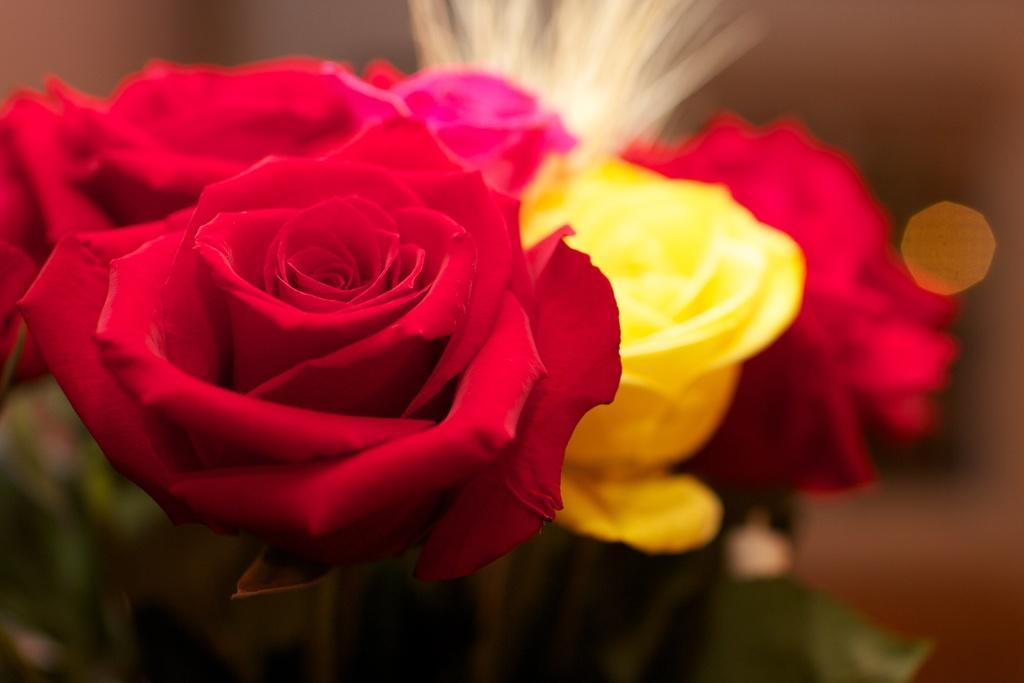Please provide a concise description of this image. In this image we can see the flowers. The background is blurry. 